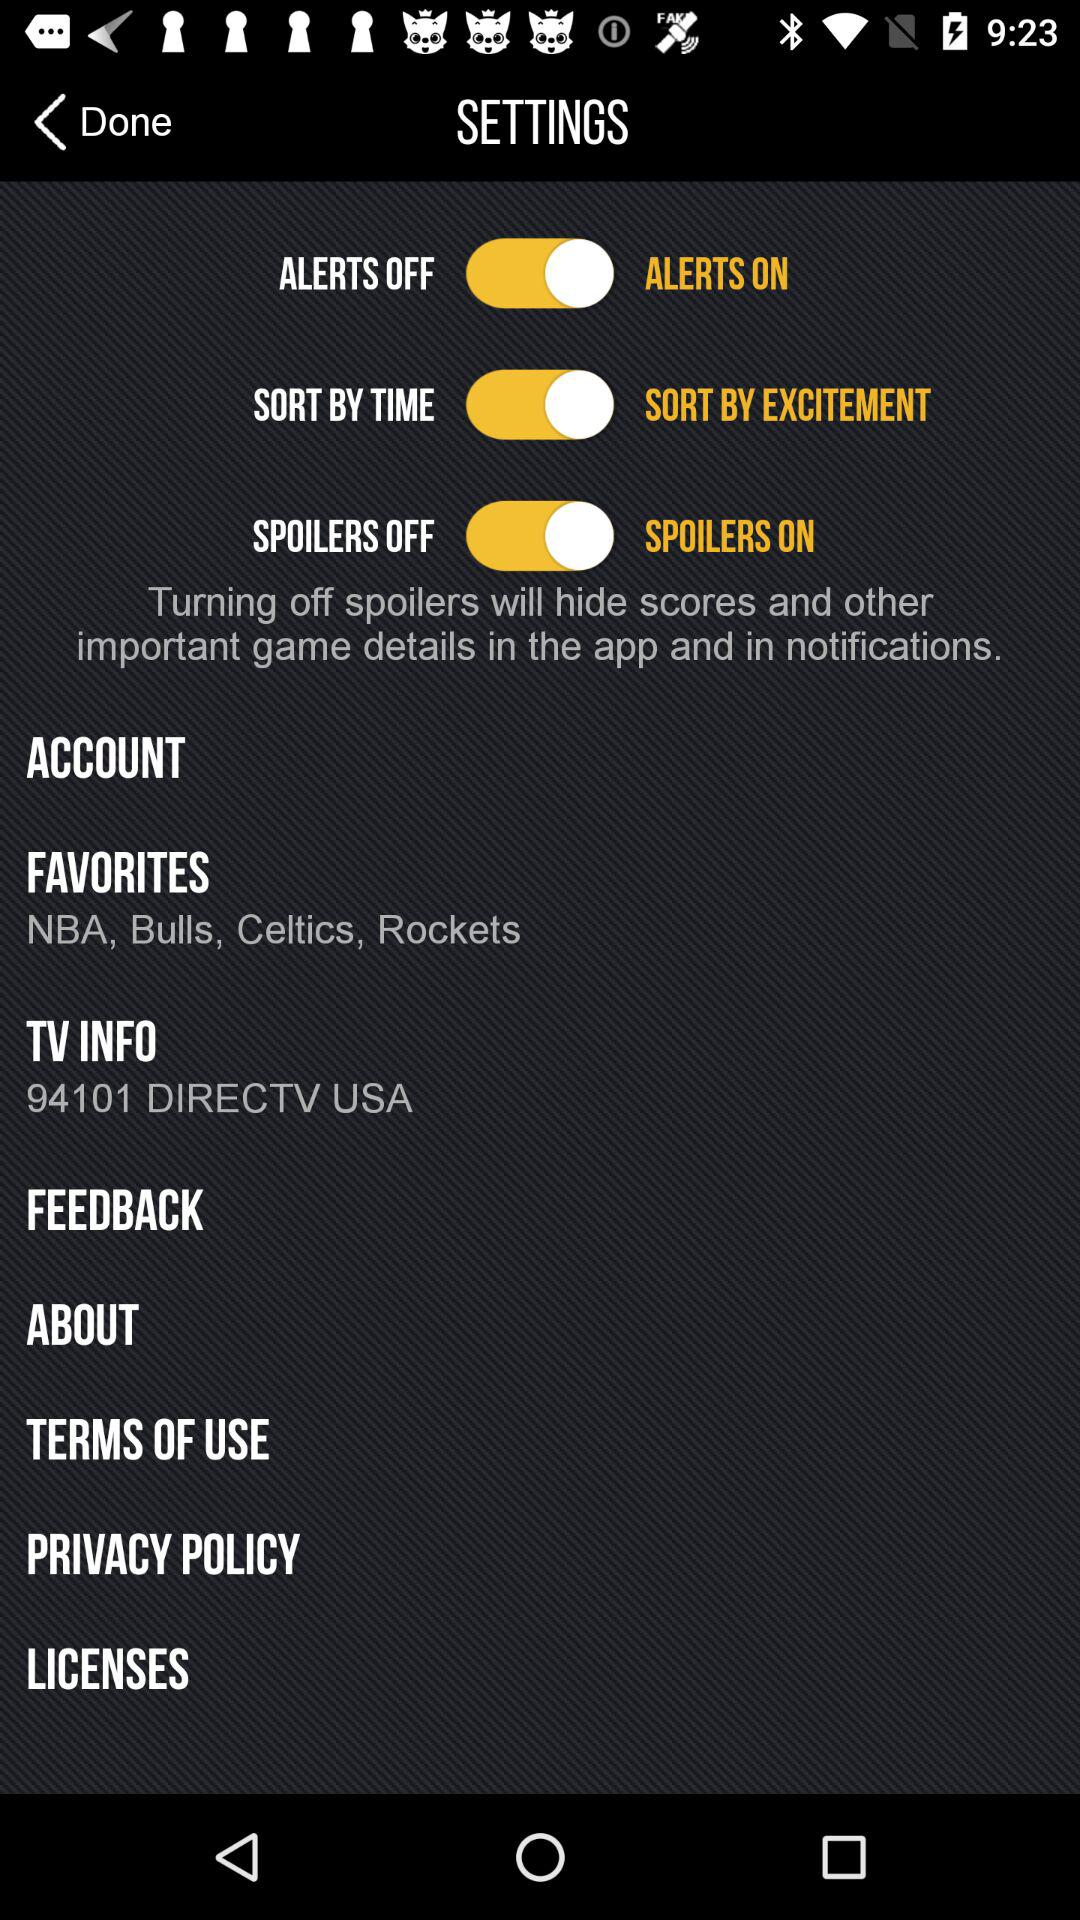What is the status of "ALERTS"? The status of "ALERTS" is "on". 